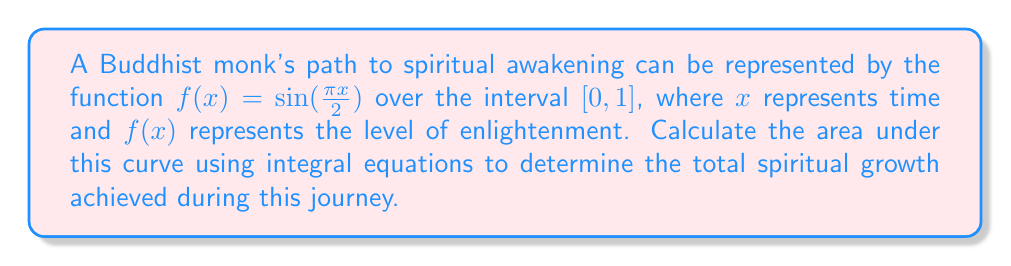Can you answer this question? To calculate the area under the curve, we need to integrate the function $f(x) = \sin(\frac{\pi x}{2})$ over the interval $[0, 1]$. Let's approach this step-by-step:

1) The integral we need to solve is:

   $$\int_0^1 \sin(\frac{\pi x}{2}) dx$$

2) To solve this, we can use the substitution method. Let $u = \frac{\pi x}{2}$. Then:

   $du = \frac{\pi}{2} dx$
   $dx = \frac{2}{\pi} du$

3) When $x = 0$, $u = 0$
   When $x = 1$, $u = \frac{\pi}{2}$

4) Substituting these into our integral:

   $$\int_0^{\frac{\pi}{2}} \sin(u) \cdot \frac{2}{\pi} du$$

5) This simplifies to:

   $$\frac{2}{\pi} \int_0^{\frac{\pi}{2}} \sin(u) du$$

6) The integral of $\sin(u)$ is $-\cos(u)$, so:

   $$\frac{2}{\pi} [-\cos(u)]_0^{\frac{\pi}{2}}$$

7) Evaluating the limits:

   $$\frac{2}{\pi} [-\cos(\frac{\pi}{2}) - (-\cos(0))]$$

8) We know that $\cos(\frac{\pi}{2}) = 0$ and $\cos(0) = 1$, so:

   $$\frac{2}{\pi} [0 - (-1)] = \frac{2}{\pi}$$

Therefore, the area under the curve, representing the total spiritual growth, is $\frac{2}{\pi}$.
Answer: $\frac{2}{\pi}$ 